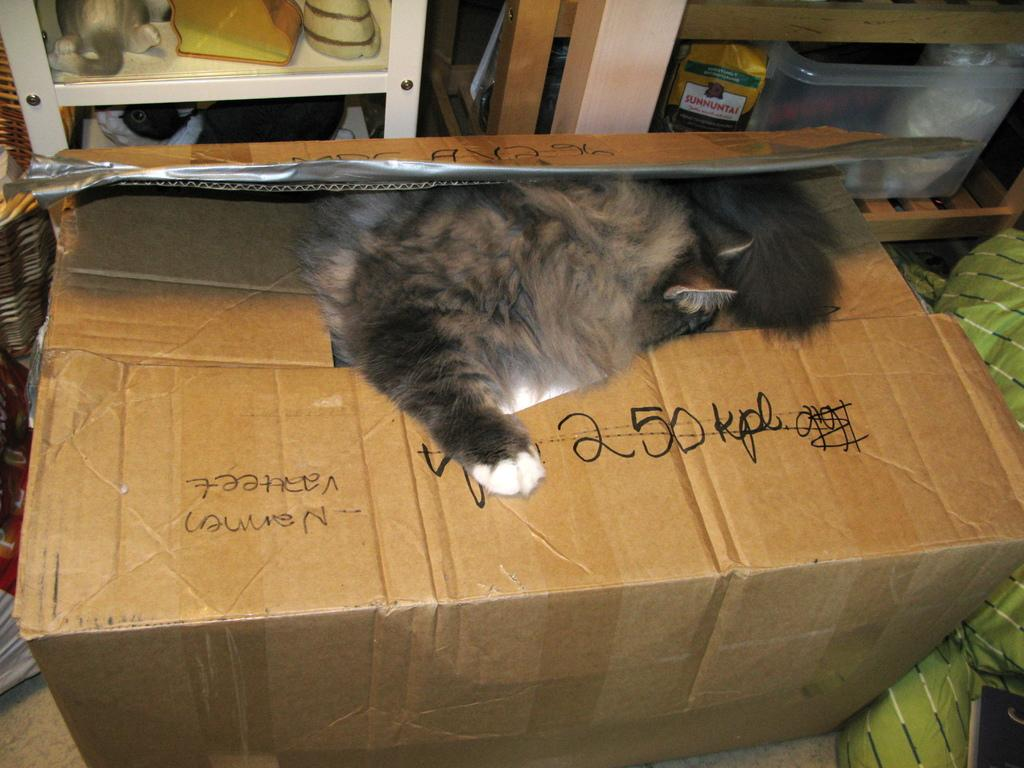Provide a one-sentence caption for the provided image. A cat laying on top of a box with 250 kpl written in sharpie on top. 